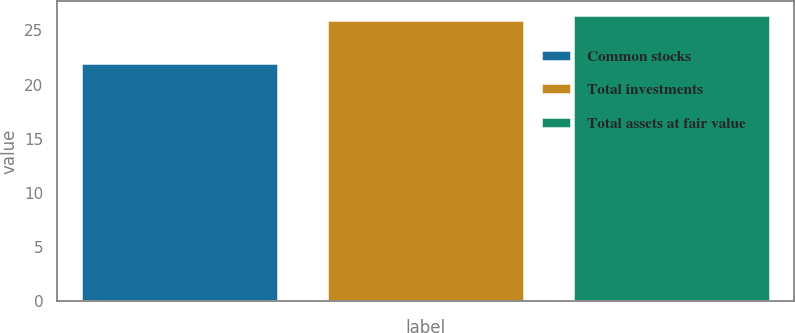Convert chart to OTSL. <chart><loc_0><loc_0><loc_500><loc_500><bar_chart><fcel>Common stocks<fcel>Total investments<fcel>Total assets at fair value<nl><fcel>22<fcel>26<fcel>26.4<nl></chart> 